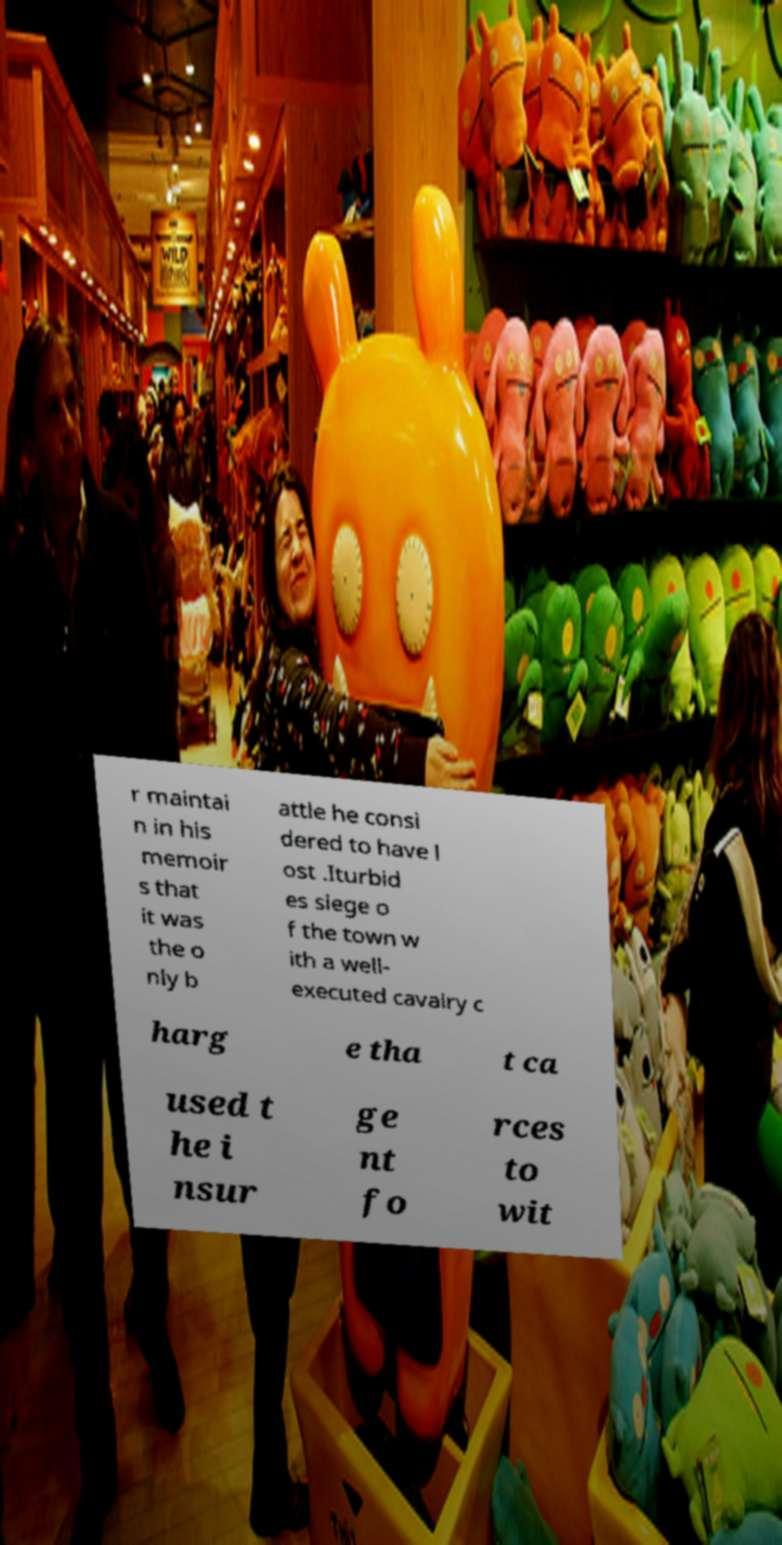Please identify and transcribe the text found in this image. r maintai n in his memoir s that it was the o nly b attle he consi dered to have l ost .Iturbid es siege o f the town w ith a well- executed cavalry c harg e tha t ca used t he i nsur ge nt fo rces to wit 